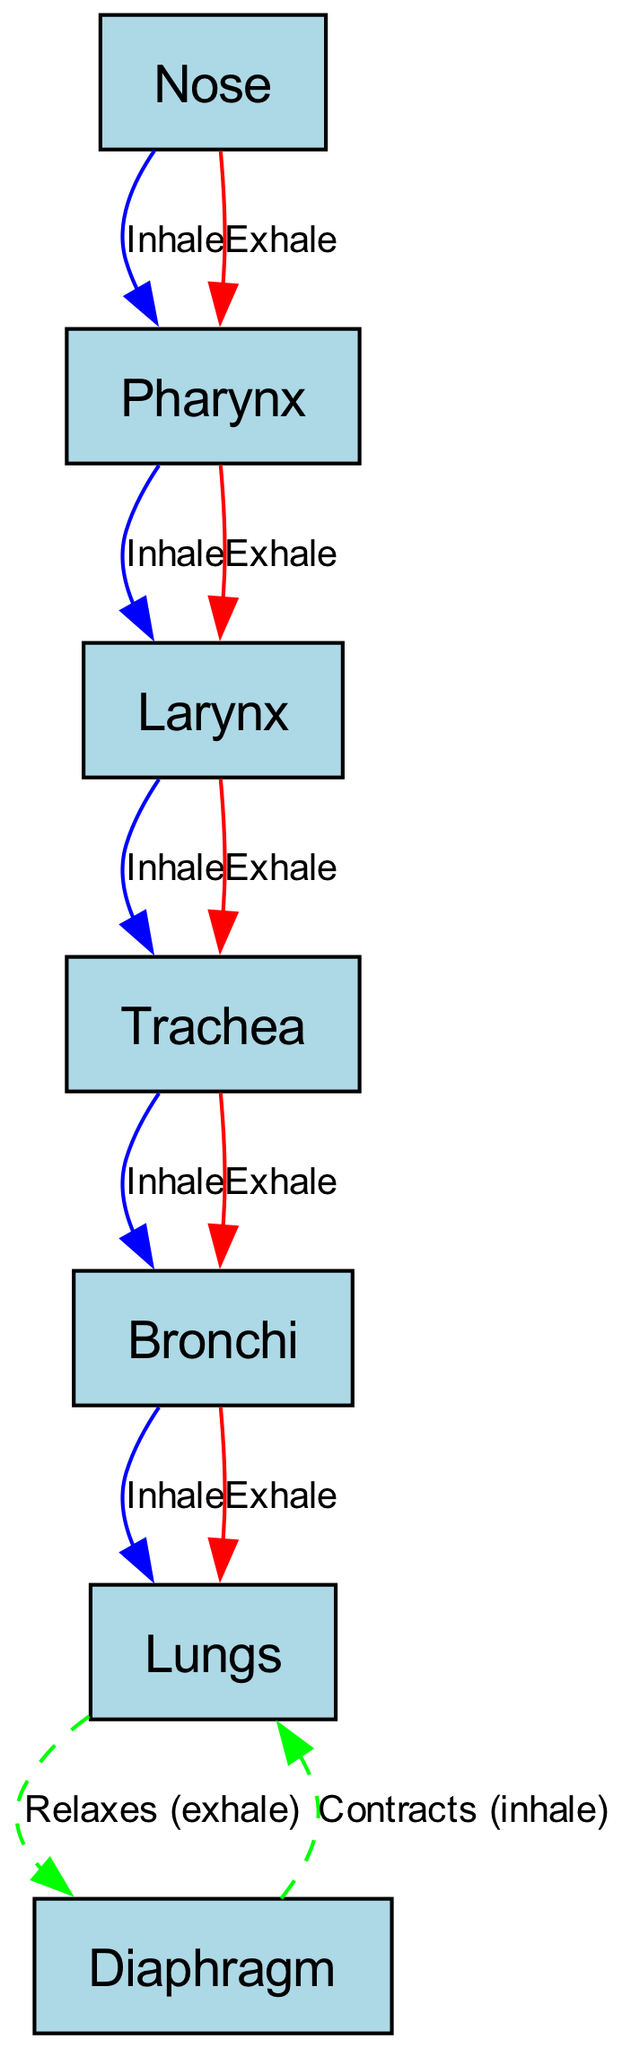What is the first organ involved in inhalation? In the diagram, the arrows indicate the direction of airflow during inhalation. The first organ listed that receives air is the nose, as it is the starting point in the inhalation pathway.
Answer: Nose How many organs are involved in the inhalation process? The inhalation process starts from the nose and goes through the pharynx, larynx, trachea, bronchi, and ends in the lungs. Counting these, there are five organs involved in inhalation.
Answer: Five What color represents inhalation in the diagram? The edges representing inhalation are colored blue, which distinguishes them from the edges representing exhalation and other actions in the diagram.
Answer: Blue Which organ does the diaphragm contract to assist in inhalation? The diagram shows that the diaphragm contracts to help expand the lungs during inhalation. This indicates that the diaphragm works directly with the lungs.
Answer: Lungs What is the direction of airflow when exhaling? The diagram provides a clear path for exhalation. The flow goes from the lungs back to the nose in a sequence through the bronchi, trachea, larynx, and pharynx. Therefore, the direction is from lungs to nose.
Answer: From lungs to nose What is the last organ before air exits the respiratory system during exhalation? Looking at the exhalation pathway, the last organ air passes through before it exits is the pharynx, as it takes the air from the larynx to the nose.
Answer: Pharynx How many total edges are there in the diagram? By counting the relationships (edges) shown in the diagram, there are 11 directed edges representing both inhalation and exhalation pathways.
Answer: Eleven Which label indicates the relaxed state of the diaphragm? The diagram specifies the action of the diaphragm during exhalation as it relaxes when the lungs expel air, distinctly marked as "Relaxes (exhale)".
Answer: Relaxes (exhale) 